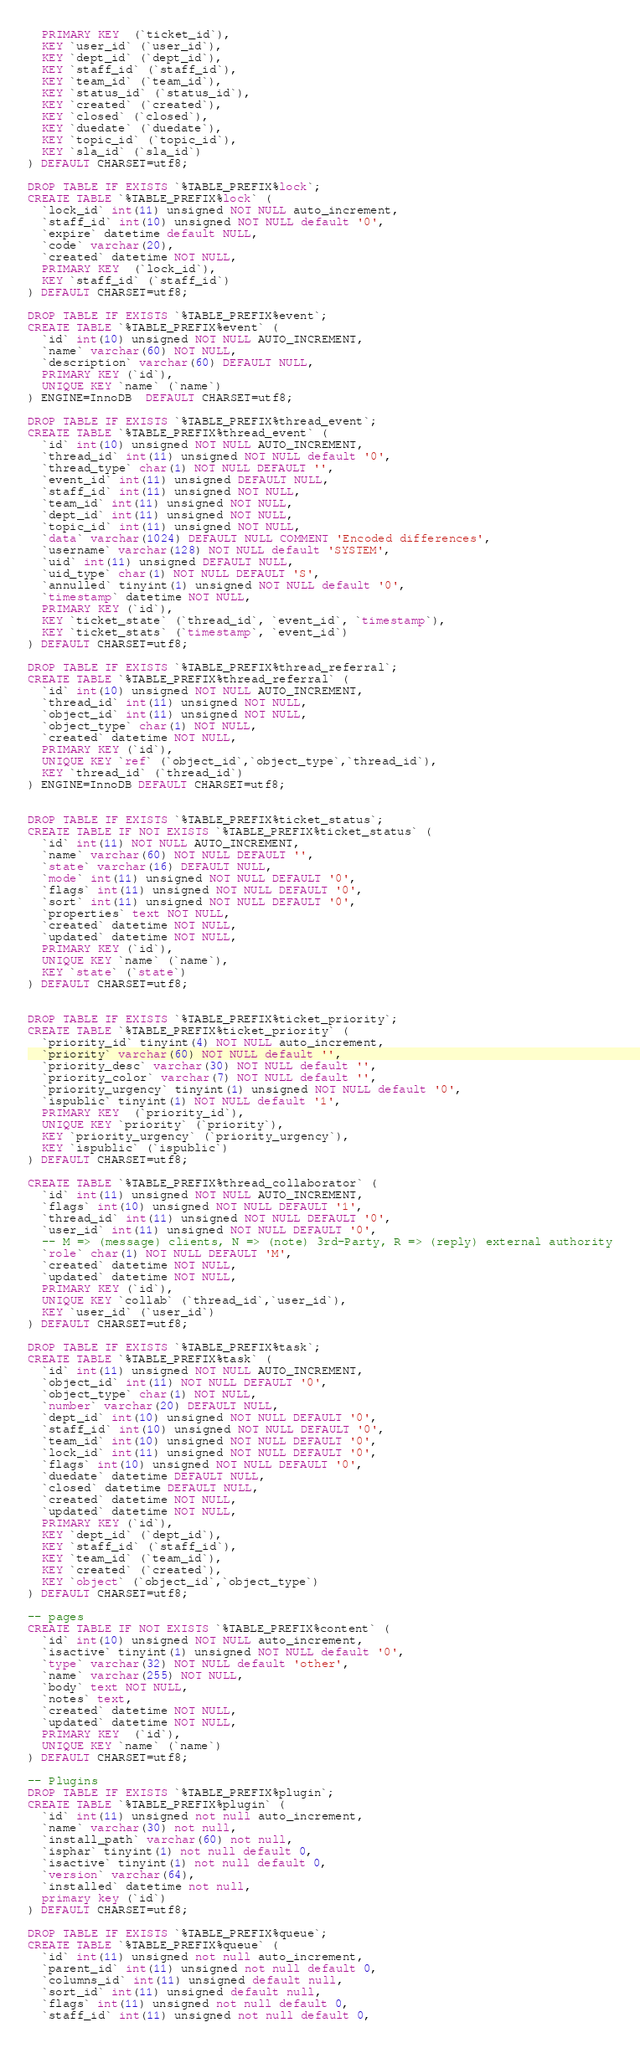Convert code to text. <code><loc_0><loc_0><loc_500><loc_500><_SQL_>  PRIMARY KEY  (`ticket_id`),
  KEY `user_id` (`user_id`),
  KEY `dept_id` (`dept_id`),
  KEY `staff_id` (`staff_id`),
  KEY `team_id` (`team_id`),
  KEY `status_id` (`status_id`),
  KEY `created` (`created`),
  KEY `closed` (`closed`),
  KEY `duedate` (`duedate`),
  KEY `topic_id` (`topic_id`),
  KEY `sla_id` (`sla_id`)
) DEFAULT CHARSET=utf8;

DROP TABLE IF EXISTS `%TABLE_PREFIX%lock`;
CREATE TABLE `%TABLE_PREFIX%lock` (
  `lock_id` int(11) unsigned NOT NULL auto_increment,
  `staff_id` int(10) unsigned NOT NULL default '0',
  `expire` datetime default NULL,
  `code` varchar(20),
  `created` datetime NOT NULL,
  PRIMARY KEY  (`lock_id`),
  KEY `staff_id` (`staff_id`)
) DEFAULT CHARSET=utf8;

DROP TABLE IF EXISTS `%TABLE_PREFIX%event`;
CREATE TABLE `%TABLE_PREFIX%event` (
  `id` int(10) unsigned NOT NULL AUTO_INCREMENT,
  `name` varchar(60) NOT NULL,
  `description` varchar(60) DEFAULT NULL,
  PRIMARY KEY (`id`),
  UNIQUE KEY `name` (`name`)
) ENGINE=InnoDB  DEFAULT CHARSET=utf8;

DROP TABLE IF EXISTS `%TABLE_PREFIX%thread_event`;
CREATE TABLE `%TABLE_PREFIX%thread_event` (
  `id` int(10) unsigned NOT NULL AUTO_INCREMENT,
  `thread_id` int(11) unsigned NOT NULL default '0',
  `thread_type` char(1) NOT NULL DEFAULT '',
  `event_id` int(11) unsigned DEFAULT NULL,
  `staff_id` int(11) unsigned NOT NULL,
  `team_id` int(11) unsigned NOT NULL,
  `dept_id` int(11) unsigned NOT NULL,
  `topic_id` int(11) unsigned NOT NULL,
  `data` varchar(1024) DEFAULT NULL COMMENT 'Encoded differences',
  `username` varchar(128) NOT NULL default 'SYSTEM',
  `uid` int(11) unsigned DEFAULT NULL,
  `uid_type` char(1) NOT NULL DEFAULT 'S',
  `annulled` tinyint(1) unsigned NOT NULL default '0',
  `timestamp` datetime NOT NULL,
  PRIMARY KEY (`id`),
  KEY `ticket_state` (`thread_id`, `event_id`, `timestamp`),
  KEY `ticket_stats` (`timestamp`, `event_id`)
) DEFAULT CHARSET=utf8;

DROP TABLE IF EXISTS `%TABLE_PREFIX%thread_referral`;
CREATE TABLE `%TABLE_PREFIX%thread_referral` (
  `id` int(10) unsigned NOT NULL AUTO_INCREMENT,
  `thread_id` int(11) unsigned NOT NULL,
  `object_id` int(11) unsigned NOT NULL,
  `object_type` char(1) NOT NULL,
  `created` datetime NOT NULL,
  PRIMARY KEY (`id`),
  UNIQUE KEY `ref` (`object_id`,`object_type`,`thread_id`),
  KEY `thread_id` (`thread_id`)
) ENGINE=InnoDB DEFAULT CHARSET=utf8;


DROP TABLE IF EXISTS `%TABLE_PREFIX%ticket_status`;
CREATE TABLE IF NOT EXISTS `%TABLE_PREFIX%ticket_status` (
  `id` int(11) NOT NULL AUTO_INCREMENT,
  `name` varchar(60) NOT NULL DEFAULT '',
  `state` varchar(16) DEFAULT NULL,
  `mode` int(11) unsigned NOT NULL DEFAULT '0',
  `flags` int(11) unsigned NOT NULL DEFAULT '0',
  `sort` int(11) unsigned NOT NULL DEFAULT '0',
  `properties` text NOT NULL,
  `created` datetime NOT NULL,
  `updated` datetime NOT NULL,
  PRIMARY KEY (`id`),
  UNIQUE KEY `name` (`name`),
  KEY `state` (`state`)
) DEFAULT CHARSET=utf8;


DROP TABLE IF EXISTS `%TABLE_PREFIX%ticket_priority`;
CREATE TABLE `%TABLE_PREFIX%ticket_priority` (
  `priority_id` tinyint(4) NOT NULL auto_increment,
  `priority` varchar(60) NOT NULL default '',
  `priority_desc` varchar(30) NOT NULL default '',
  `priority_color` varchar(7) NOT NULL default '',
  `priority_urgency` tinyint(1) unsigned NOT NULL default '0',
  `ispublic` tinyint(1) NOT NULL default '1',
  PRIMARY KEY  (`priority_id`),
  UNIQUE KEY `priority` (`priority`),
  KEY `priority_urgency` (`priority_urgency`),
  KEY `ispublic` (`ispublic`)
) DEFAULT CHARSET=utf8;

CREATE TABLE `%TABLE_PREFIX%thread_collaborator` (
  `id` int(11) unsigned NOT NULL AUTO_INCREMENT,
  `flags` int(10) unsigned NOT NULL DEFAULT '1',
  `thread_id` int(11) unsigned NOT NULL DEFAULT '0',
  `user_id` int(11) unsigned NOT NULL DEFAULT '0',
  -- M => (message) clients, N => (note) 3rd-Party, R => (reply) external authority
  `role` char(1) NOT NULL DEFAULT 'M',
  `created` datetime NOT NULL,
  `updated` datetime NOT NULL,
  PRIMARY KEY (`id`),
  UNIQUE KEY `collab` (`thread_id`,`user_id`),
  KEY `user_id` (`user_id`)
) DEFAULT CHARSET=utf8;

DROP TABLE IF EXISTS `%TABLE_PREFIX%task`;
CREATE TABLE `%TABLE_PREFIX%task` (
  `id` int(11) unsigned NOT NULL AUTO_INCREMENT,
  `object_id` int(11) NOT NULL DEFAULT '0',
  `object_type` char(1) NOT NULL,
  `number` varchar(20) DEFAULT NULL,
  `dept_id` int(10) unsigned NOT NULL DEFAULT '0',
  `staff_id` int(10) unsigned NOT NULL DEFAULT '0',
  `team_id` int(10) unsigned NOT NULL DEFAULT '0',
  `lock_id` int(11) unsigned NOT NULL DEFAULT '0',
  `flags` int(10) unsigned NOT NULL DEFAULT '0',
  `duedate` datetime DEFAULT NULL,
  `closed` datetime DEFAULT NULL,
  `created` datetime NOT NULL,
  `updated` datetime NOT NULL,
  PRIMARY KEY (`id`),
  KEY `dept_id` (`dept_id`),
  KEY `staff_id` (`staff_id`),
  KEY `team_id` (`team_id`),
  KEY `created` (`created`),
  KEY `object` (`object_id`,`object_type`)
) DEFAULT CHARSET=utf8;

-- pages
CREATE TABLE IF NOT EXISTS `%TABLE_PREFIX%content` (
  `id` int(10) unsigned NOT NULL auto_increment,
  `isactive` tinyint(1) unsigned NOT NULL default '0',
  `type` varchar(32) NOT NULL default 'other',
  `name` varchar(255) NOT NULL,
  `body` text NOT NULL,
  `notes` text,
  `created` datetime NOT NULL,
  `updated` datetime NOT NULL,
  PRIMARY KEY  (`id`),
  UNIQUE KEY `name` (`name`)
) DEFAULT CHARSET=utf8;

-- Plugins
DROP TABLE IF EXISTS `%TABLE_PREFIX%plugin`;
CREATE TABLE `%TABLE_PREFIX%plugin` (
  `id` int(11) unsigned not null auto_increment,
  `name` varchar(30) not null,
  `install_path` varchar(60) not null,
  `isphar` tinyint(1) not null default 0,
  `isactive` tinyint(1) not null default 0,
  `version` varchar(64),
  `installed` datetime not null,
  primary key (`id`)
) DEFAULT CHARSET=utf8;

DROP TABLE IF EXISTS `%TABLE_PREFIX%queue`;
CREATE TABLE `%TABLE_PREFIX%queue` (
  `id` int(11) unsigned not null auto_increment,
  `parent_id` int(11) unsigned not null default 0,
  `columns_id` int(11) unsigned default null,
  `sort_id` int(11) unsigned default null,
  `flags` int(11) unsigned not null default 0,
  `staff_id` int(11) unsigned not null default 0,</code> 